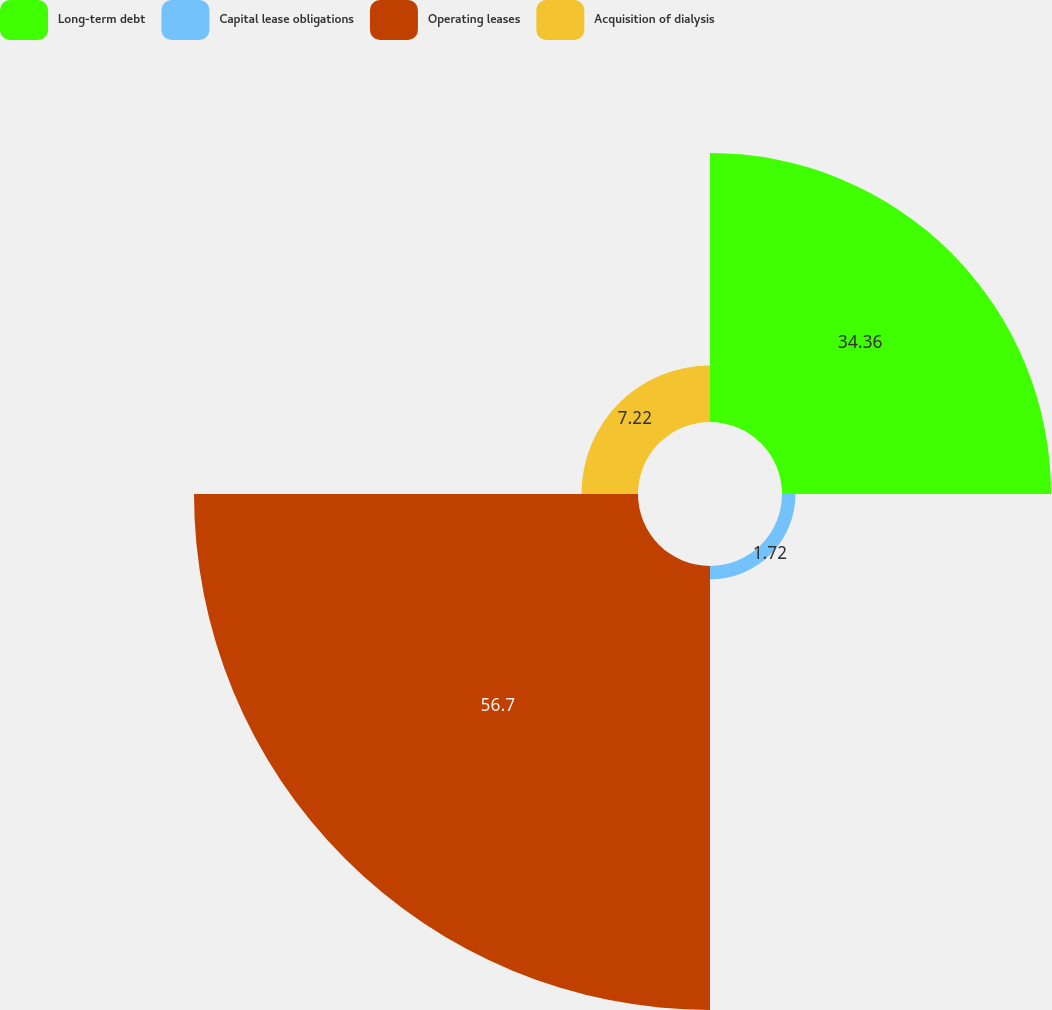Convert chart. <chart><loc_0><loc_0><loc_500><loc_500><pie_chart><fcel>Long-term debt<fcel>Capital lease obligations<fcel>Operating leases<fcel>Acquisition of dialysis<nl><fcel>34.36%<fcel>1.72%<fcel>56.7%<fcel>7.22%<nl></chart> 